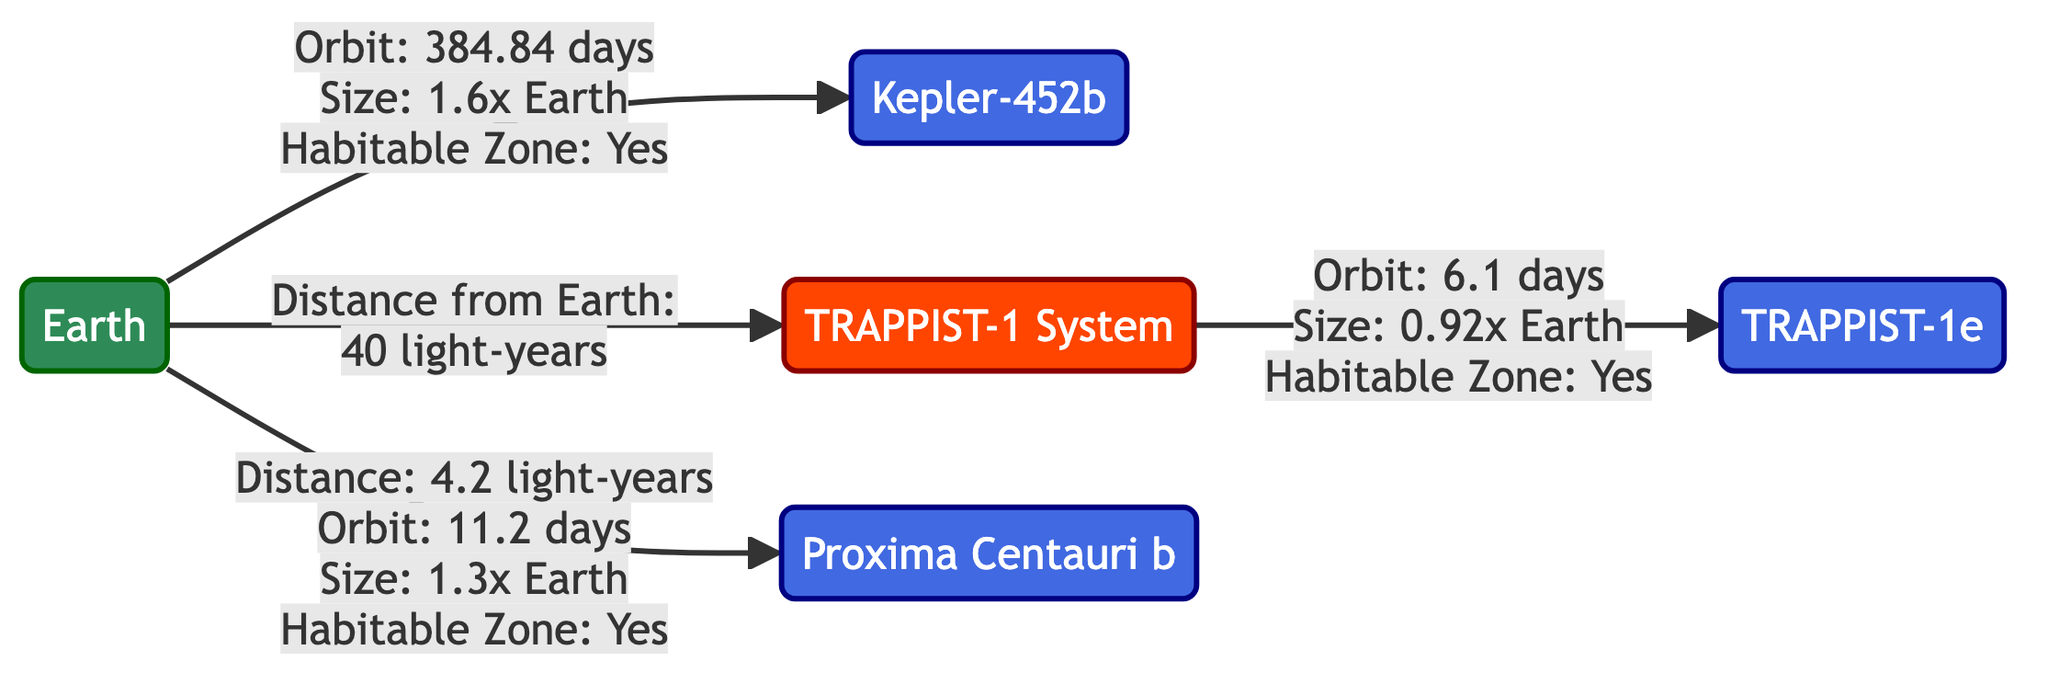What is the size of Kepler-452b compared to Earth? The diagram states that Kepler-452b is 1.6 times the size of Earth. Therefore, the answer is derived directly from the annotation connecting Earth to Kepler-452b.
Answer: 1.6x Earth What is the distance from Earth to TRAPPIST-1? According to the diagram, the distance from Earth to the TRAPPIST-1 System is 40 light-years, which is clearly indicated in the connection from Earth to TRAPPIST-1.
Answer: 40 light-years Which exoplanet in the diagram has the shortest orbital period? By comparing the orbit durations listed, TRAPPIST-1e has an orbit of 6.1 days, which is shorter than the other mentioned exoplanets (Kepler-452b, Proxima Centauri b). Hence, after evaluating all orbit links, this is the correct answer.
Answer: 6.1 days How many exoplanets are displayed in the diagram? The diagram shows three exoplanets: Kepler-452b, TRAPPIST-1e, and Proxima Centauri b. Counting the exoplanets while excluding Earth and TRAPPIST-1 system nodes leads directly to this count.
Answer: 3 Which exoplanet has a habitable zone? The diagram indicates that both Kepler-452b, TRAPPIST-1e, and Proxima Centauri b are in the habitable zone. By reviewing the connections and noting which exoplanets mention "Habitable Zone: Yes," the answer is found.
Answer: Kepler-452b, TRAPPIST-1e, Proxima Centauri b What is the orbital period of Proxima Centauri b? The diagram specifies that Proxima Centauri b has an orbital period of 11.2 days. This information is directly located in the annotation attached to Proxima Centauri b.
Answer: 11.2 days What is the size of TRAPPIST-1e compared to Earth? The size of TRAPPIST-1e is shown to be 0.92 times the size of Earth in the connection from TRAPPIST-1 to TRAPPIST-1e. This is how the answer can be directly extracted.
Answer: 0.92x Earth What color represents exoplanets in the diagram? The color assigned to exoplanets in the diagram is blue, as inferred from the defined class for exoplanets, which indicates color coding.
Answer: Blue Which system includes the exoplanet TRAPPIST-1e? The diagram shows that TRAPPIST-1e is part of the TRAPPIST-1 System, as indicated by the connection from TRAPPIST-1 to TRAPPIST-1e, clearly labeling the system's name.
Answer: TRAPPIST-1 System 